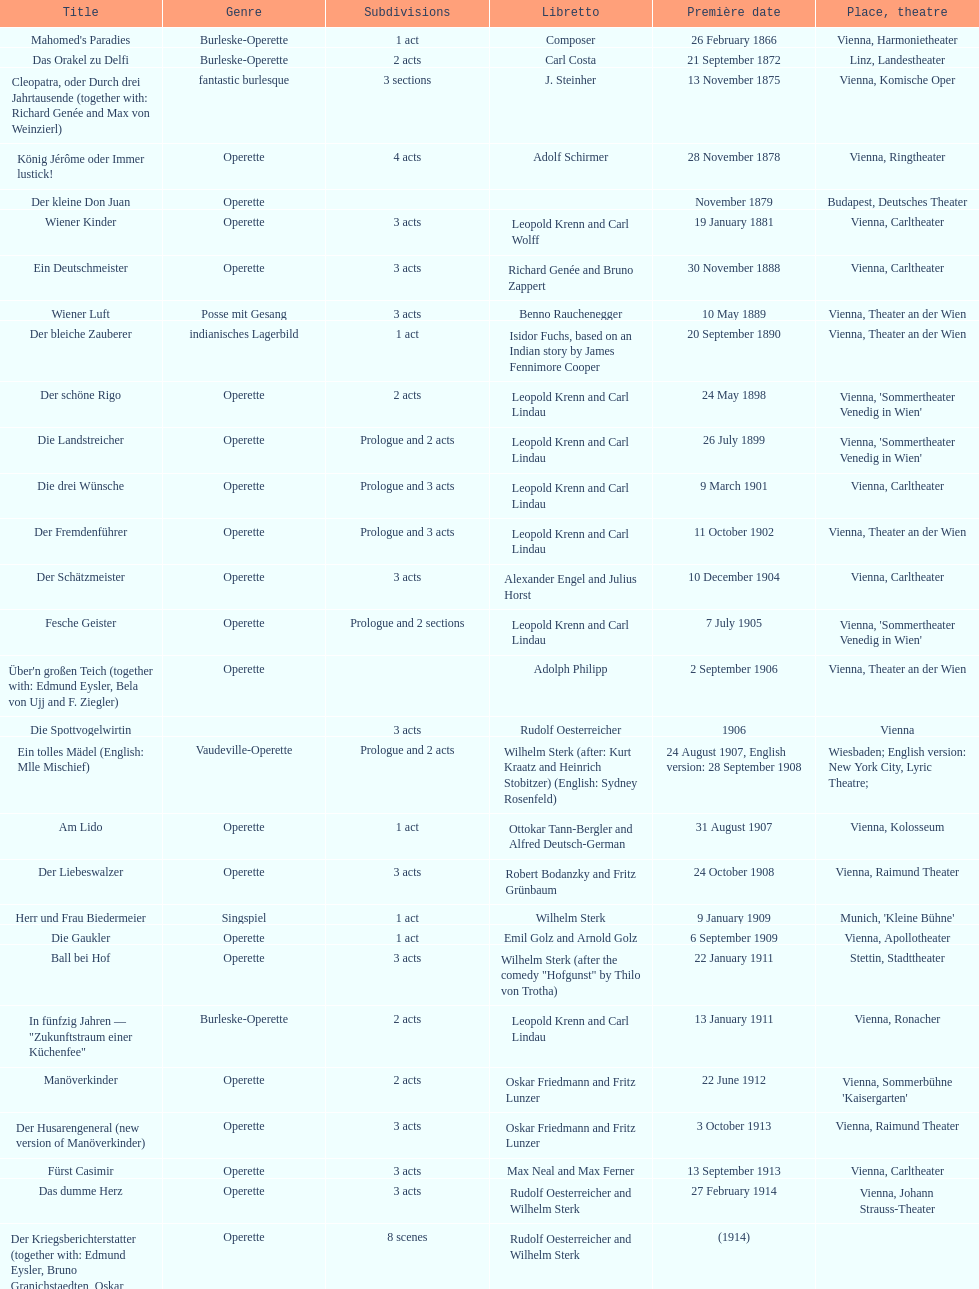How many of his operettas were 3 acts? 13. 